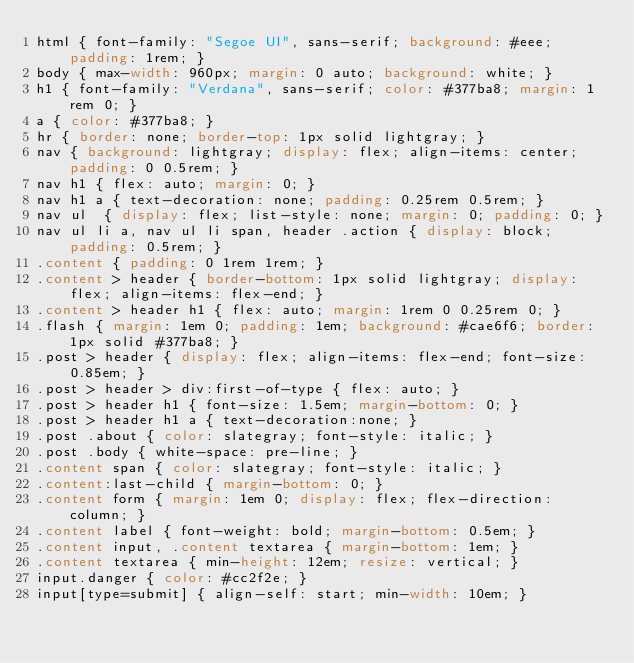Convert code to text. <code><loc_0><loc_0><loc_500><loc_500><_CSS_>html { font-family: "Segoe UI", sans-serif; background: #eee; padding: 1rem; }
body { max-width: 960px; margin: 0 auto; background: white; }
h1 { font-family: "Verdana", sans-serif; color: #377ba8; margin: 1rem 0; }
a { color: #377ba8; }
hr { border: none; border-top: 1px solid lightgray; }
nav { background: lightgray; display: flex; align-items: center; padding: 0 0.5rem; }
nav h1 { flex: auto; margin: 0; }
nav h1 a { text-decoration: none; padding: 0.25rem 0.5rem; }
nav ul  { display: flex; list-style: none; margin: 0; padding: 0; }
nav ul li a, nav ul li span, header .action { display: block; padding: 0.5rem; }
.content { padding: 0 1rem 1rem; }
.content > header { border-bottom: 1px solid lightgray; display: flex; align-items: flex-end; }
.content > header h1 { flex: auto; margin: 1rem 0 0.25rem 0; }
.flash { margin: 1em 0; padding: 1em; background: #cae6f6; border: 1px solid #377ba8; }
.post > header { display: flex; align-items: flex-end; font-size: 0.85em; }
.post > header > div:first-of-type { flex: auto; }
.post > header h1 { font-size: 1.5em; margin-bottom: 0; }
.post > header h1 a { text-decoration:none; }
.post .about { color: slategray; font-style: italic; }
.post .body { white-space: pre-line; }
.content span { color: slategray; font-style: italic; }
.content:last-child { margin-bottom: 0; }
.content form { margin: 1em 0; display: flex; flex-direction: column; }
.content label { font-weight: bold; margin-bottom: 0.5em; }
.content input, .content textarea { margin-bottom: 1em; }
.content textarea { min-height: 12em; resize: vertical; }
input.danger { color: #cc2f2e; }
input[type=submit] { align-self: start; min-width: 10em; }</code> 